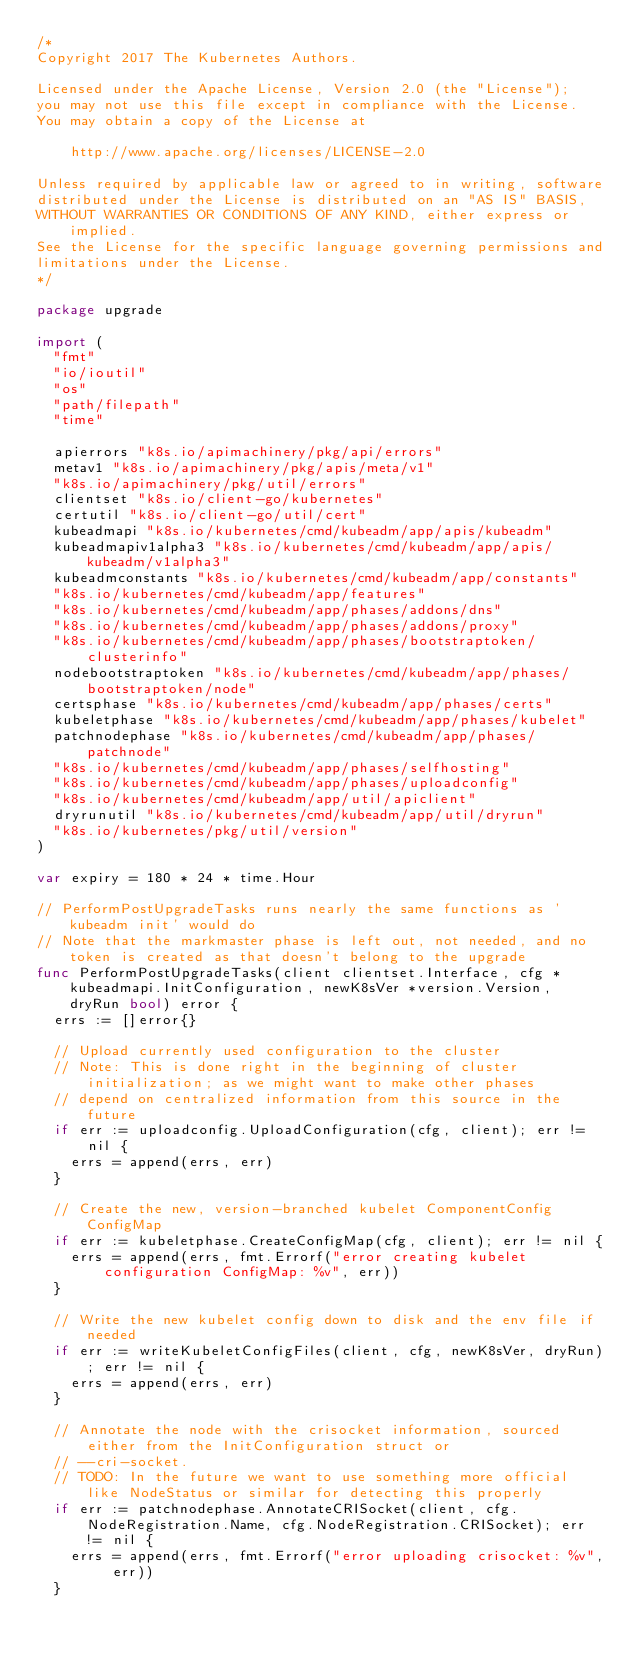Convert code to text. <code><loc_0><loc_0><loc_500><loc_500><_Go_>/*
Copyright 2017 The Kubernetes Authors.

Licensed under the Apache License, Version 2.0 (the "License");
you may not use this file except in compliance with the License.
You may obtain a copy of the License at

    http://www.apache.org/licenses/LICENSE-2.0

Unless required by applicable law or agreed to in writing, software
distributed under the License is distributed on an "AS IS" BASIS,
WITHOUT WARRANTIES OR CONDITIONS OF ANY KIND, either express or implied.
See the License for the specific language governing permissions and
limitations under the License.
*/

package upgrade

import (
	"fmt"
	"io/ioutil"
	"os"
	"path/filepath"
	"time"

	apierrors "k8s.io/apimachinery/pkg/api/errors"
	metav1 "k8s.io/apimachinery/pkg/apis/meta/v1"
	"k8s.io/apimachinery/pkg/util/errors"
	clientset "k8s.io/client-go/kubernetes"
	certutil "k8s.io/client-go/util/cert"
	kubeadmapi "k8s.io/kubernetes/cmd/kubeadm/app/apis/kubeadm"
	kubeadmapiv1alpha3 "k8s.io/kubernetes/cmd/kubeadm/app/apis/kubeadm/v1alpha3"
	kubeadmconstants "k8s.io/kubernetes/cmd/kubeadm/app/constants"
	"k8s.io/kubernetes/cmd/kubeadm/app/features"
	"k8s.io/kubernetes/cmd/kubeadm/app/phases/addons/dns"
	"k8s.io/kubernetes/cmd/kubeadm/app/phases/addons/proxy"
	"k8s.io/kubernetes/cmd/kubeadm/app/phases/bootstraptoken/clusterinfo"
	nodebootstraptoken "k8s.io/kubernetes/cmd/kubeadm/app/phases/bootstraptoken/node"
	certsphase "k8s.io/kubernetes/cmd/kubeadm/app/phases/certs"
	kubeletphase "k8s.io/kubernetes/cmd/kubeadm/app/phases/kubelet"
	patchnodephase "k8s.io/kubernetes/cmd/kubeadm/app/phases/patchnode"
	"k8s.io/kubernetes/cmd/kubeadm/app/phases/selfhosting"
	"k8s.io/kubernetes/cmd/kubeadm/app/phases/uploadconfig"
	"k8s.io/kubernetes/cmd/kubeadm/app/util/apiclient"
	dryrunutil "k8s.io/kubernetes/cmd/kubeadm/app/util/dryrun"
	"k8s.io/kubernetes/pkg/util/version"
)

var expiry = 180 * 24 * time.Hour

// PerformPostUpgradeTasks runs nearly the same functions as 'kubeadm init' would do
// Note that the markmaster phase is left out, not needed, and no token is created as that doesn't belong to the upgrade
func PerformPostUpgradeTasks(client clientset.Interface, cfg *kubeadmapi.InitConfiguration, newK8sVer *version.Version, dryRun bool) error {
	errs := []error{}

	// Upload currently used configuration to the cluster
	// Note: This is done right in the beginning of cluster initialization; as we might want to make other phases
	// depend on centralized information from this source in the future
	if err := uploadconfig.UploadConfiguration(cfg, client); err != nil {
		errs = append(errs, err)
	}

	// Create the new, version-branched kubelet ComponentConfig ConfigMap
	if err := kubeletphase.CreateConfigMap(cfg, client); err != nil {
		errs = append(errs, fmt.Errorf("error creating kubelet configuration ConfigMap: %v", err))
	}

	// Write the new kubelet config down to disk and the env file if needed
	if err := writeKubeletConfigFiles(client, cfg, newK8sVer, dryRun); err != nil {
		errs = append(errs, err)
	}

	// Annotate the node with the crisocket information, sourced either from the InitConfiguration struct or
	// --cri-socket.
	// TODO: In the future we want to use something more official like NodeStatus or similar for detecting this properly
	if err := patchnodephase.AnnotateCRISocket(client, cfg.NodeRegistration.Name, cfg.NodeRegistration.CRISocket); err != nil {
		errs = append(errs, fmt.Errorf("error uploading crisocket: %v", err))
	}
</code> 